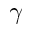Convert formula to latex. <formula><loc_0><loc_0><loc_500><loc_500>\gamma</formula> 